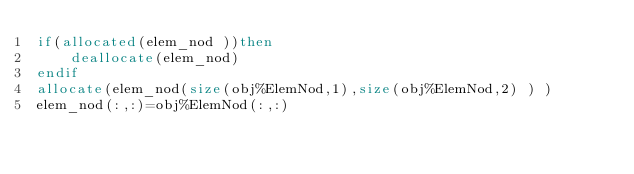Convert code to text. <code><loc_0><loc_0><loc_500><loc_500><_FORTRAN_>if(allocated(elem_nod ))then
    deallocate(elem_nod)
endif
allocate(elem_nod(size(obj%ElemNod,1),size(obj%ElemNod,2) ) )
elem_nod(:,:)=obj%ElemNod(:,:)</code> 